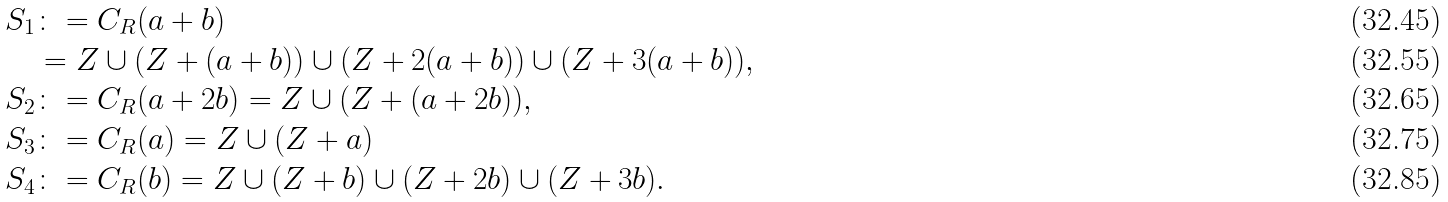<formula> <loc_0><loc_0><loc_500><loc_500>S _ { 1 } & \colon = C _ { R } ( a + b ) \\ & = Z \cup ( Z + ( a + b ) ) \cup ( Z + 2 ( a + b ) ) \cup ( Z + 3 ( a + b ) ) , \\ S _ { 2 } & \colon = C _ { R } ( a + 2 b ) = Z \cup ( Z + ( a + 2 b ) ) , \\ S _ { 3 } & \colon = C _ { R } ( a ) = Z \cup ( Z + a ) \\ S _ { 4 } & \colon = C _ { R } ( b ) = Z \cup ( Z + b ) \cup ( Z + 2 b ) \cup ( Z + 3 b ) .</formula> 